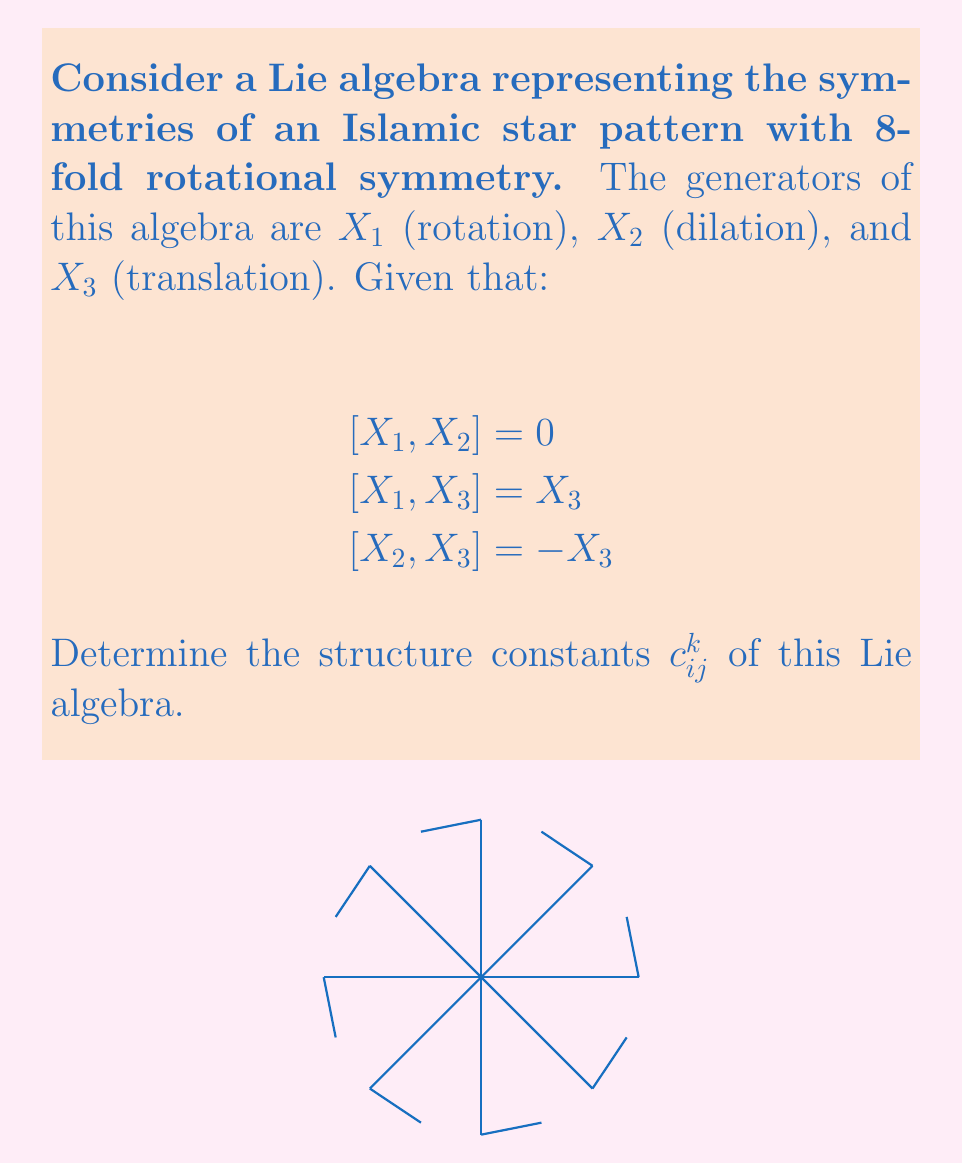Solve this math problem. To determine the structure constants $c_{ij}^k$, we need to express the Lie bracket relations in terms of these constants:

1) First, recall that for a Lie algebra with basis elements $X_i$, the structure constants are defined by:

   $$[X_i, X_j] = \sum_k c_{ij}^k X_k$$

2) Now, let's analyze each given relation:

   a) $[X_1, X_2] = 0$
      This means $c_{12}^1 = c_{12}^2 = c_{12}^3 = 0$

   b) $[X_1, X_3] = X_3$
      This implies $c_{13}^1 = c_{13}^2 = 0$ and $c_{13}^3 = 1$

   c) $[X_2, X_3] = -X_3$
      This means $c_{23}^1 = c_{23}^2 = 0$ and $c_{23}^3 = -1$

3) Due to the antisymmetry of the Lie bracket, we also know:
   
   $c_{ji}^k = -c_{ij}^k$

   This gives us the remaining constants:
   
   $c_{21}^k = -c_{12}^k = 0$ for all $k$
   $c_{31}^1 = c_{31}^2 = 0$, $c_{31}^3 = -1$
   $c_{32}^1 = c_{32}^2 = 0$, $c_{32}^3 = 1$

4) All other structure constants not mentioned are zero.

Thus, we have determined all the structure constants $c_{ij}^k$ for this Lie algebra.
Answer: $c_{13}^3 = 1$, $c_{23}^3 = -1$, $c_{31}^3 = -1$, $c_{32}^3 = 1$, all others $= 0$ 